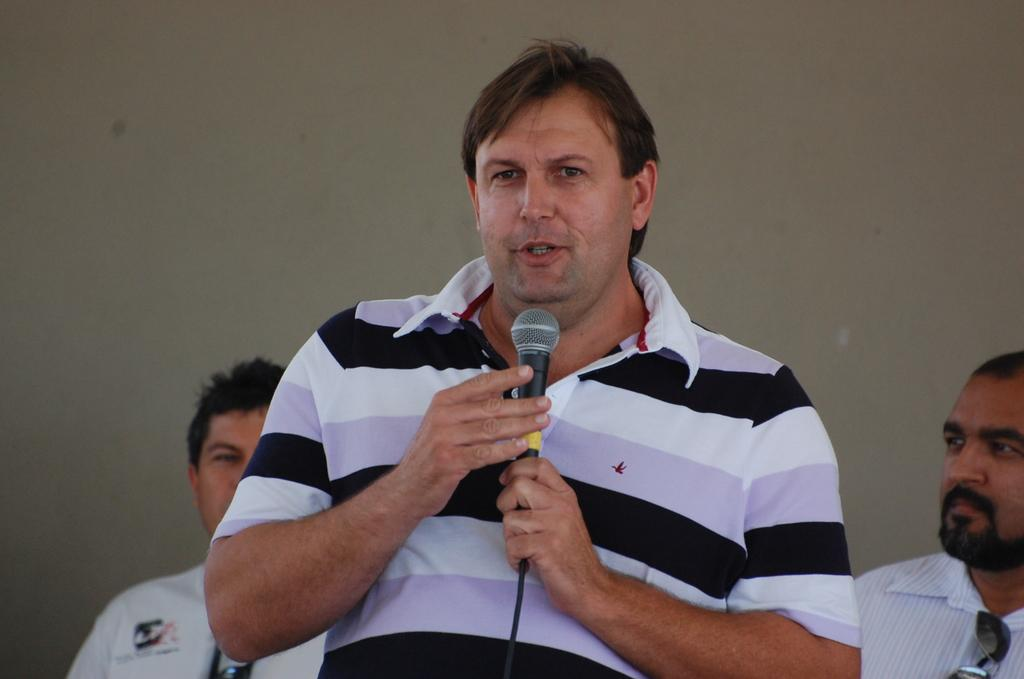What is the color of the wall in the image? There is a white color wall in the image. How many people are in the image? There are three people in the image. Can you describe the man in the image? One of the people is a man, and he is standing. What is the man holding in his hand? The man is holding a mic in his hand. What type of scent can be detected coming from the man's knee in the image? There is no mention of a knee or any scent in the image, so it is not possible to answer that question. 